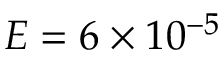Convert formula to latex. <formula><loc_0><loc_0><loc_500><loc_500>E = 6 \times 1 0 ^ { - 5 }</formula> 